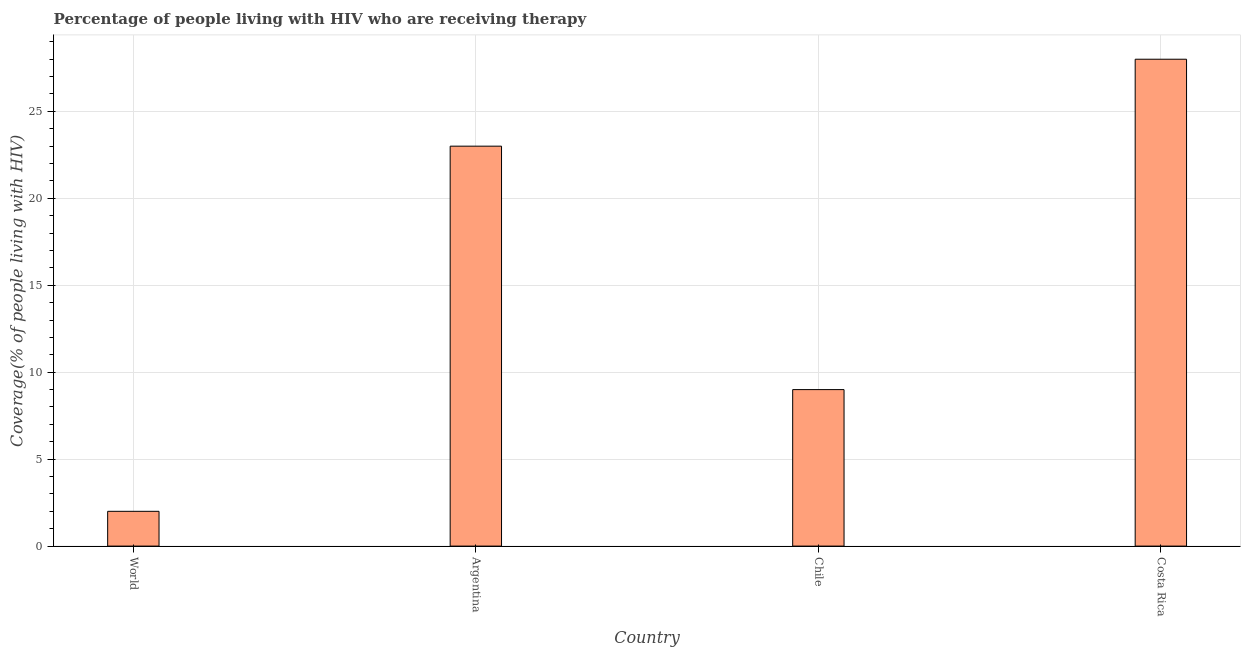What is the title of the graph?
Make the answer very short. Percentage of people living with HIV who are receiving therapy. What is the label or title of the X-axis?
Your response must be concise. Country. What is the label or title of the Y-axis?
Ensure brevity in your answer.  Coverage(% of people living with HIV). What is the antiretroviral therapy coverage in Argentina?
Provide a short and direct response. 23. Across all countries, what is the maximum antiretroviral therapy coverage?
Give a very brief answer. 28. In which country was the antiretroviral therapy coverage minimum?
Your answer should be very brief. World. What is the sum of the antiretroviral therapy coverage?
Your answer should be very brief. 62. What is the difference between the antiretroviral therapy coverage in Chile and Costa Rica?
Offer a terse response. -19. What is the average antiretroviral therapy coverage per country?
Provide a short and direct response. 15.5. What is the median antiretroviral therapy coverage?
Make the answer very short. 16. In how many countries, is the antiretroviral therapy coverage greater than 8 %?
Your response must be concise. 3. Is the antiretroviral therapy coverage in Costa Rica less than that in World?
Offer a terse response. No. Is the difference between the antiretroviral therapy coverage in Costa Rica and World greater than the difference between any two countries?
Provide a succinct answer. Yes. How many bars are there?
Offer a terse response. 4. What is the difference between two consecutive major ticks on the Y-axis?
Give a very brief answer. 5. What is the Coverage(% of people living with HIV) in World?
Your answer should be very brief. 2. What is the Coverage(% of people living with HIV) of Chile?
Keep it short and to the point. 9. What is the difference between the Coverage(% of people living with HIV) in Argentina and Chile?
Provide a succinct answer. 14. What is the difference between the Coverage(% of people living with HIV) in Argentina and Costa Rica?
Your answer should be very brief. -5. What is the difference between the Coverage(% of people living with HIV) in Chile and Costa Rica?
Make the answer very short. -19. What is the ratio of the Coverage(% of people living with HIV) in World to that in Argentina?
Your answer should be very brief. 0.09. What is the ratio of the Coverage(% of people living with HIV) in World to that in Chile?
Your answer should be compact. 0.22. What is the ratio of the Coverage(% of people living with HIV) in World to that in Costa Rica?
Provide a succinct answer. 0.07. What is the ratio of the Coverage(% of people living with HIV) in Argentina to that in Chile?
Provide a short and direct response. 2.56. What is the ratio of the Coverage(% of people living with HIV) in Argentina to that in Costa Rica?
Your response must be concise. 0.82. What is the ratio of the Coverage(% of people living with HIV) in Chile to that in Costa Rica?
Offer a very short reply. 0.32. 